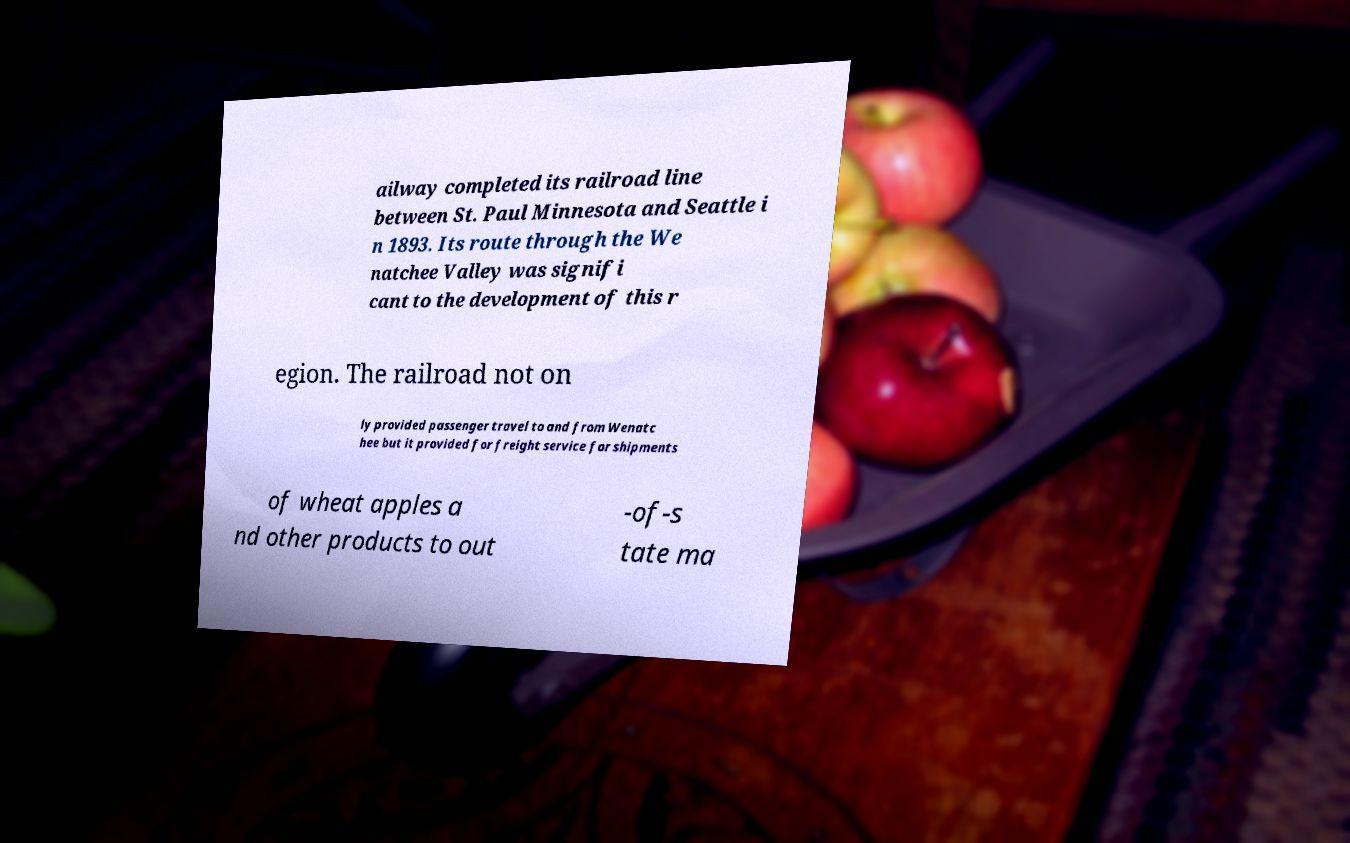There's text embedded in this image that I need extracted. Can you transcribe it verbatim? ailway completed its railroad line between St. Paul Minnesota and Seattle i n 1893. Its route through the We natchee Valley was signifi cant to the development of this r egion. The railroad not on ly provided passenger travel to and from Wenatc hee but it provided for freight service for shipments of wheat apples a nd other products to out -of-s tate ma 